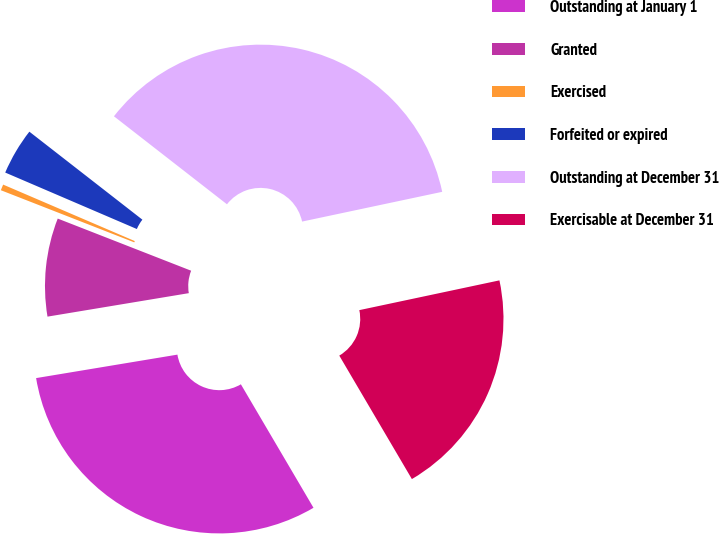Convert chart to OTSL. <chart><loc_0><loc_0><loc_500><loc_500><pie_chart><fcel>Outstanding at January 1<fcel>Granted<fcel>Exercised<fcel>Forfeited or expired<fcel>Outstanding at December 31<fcel>Exercisable at December 31<nl><fcel>30.84%<fcel>8.55%<fcel>0.52%<fcel>4.08%<fcel>36.14%<fcel>19.87%<nl></chart> 